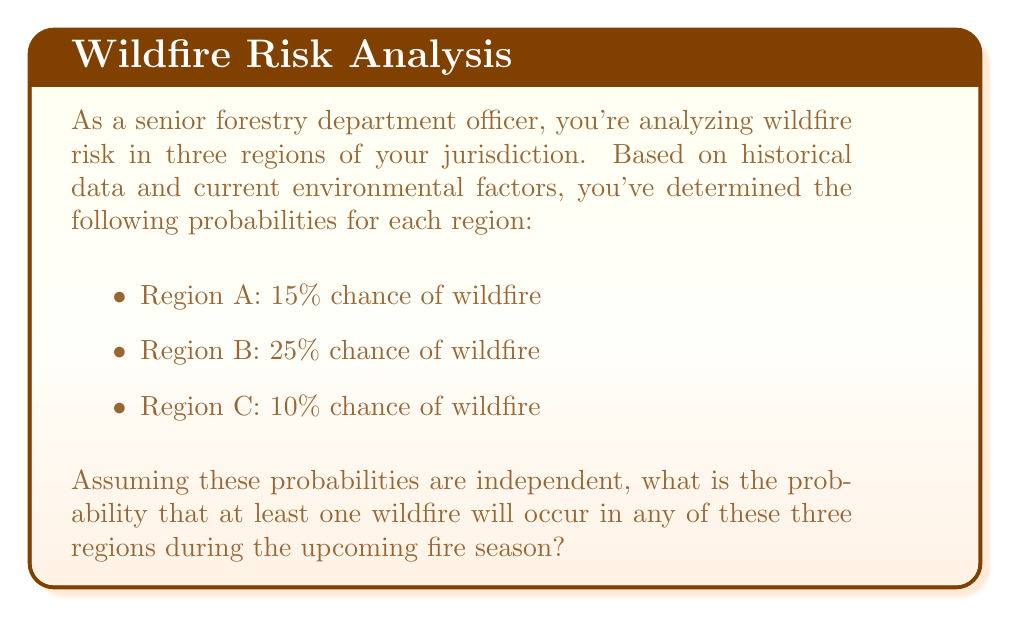Can you answer this question? To solve this problem, we'll use the complement rule of probability. Instead of calculating the probability of at least one wildfire occurring, we'll calculate the probability of no wildfires occurring and then subtract that from 1.

Let's break it down step-by-step:

1) First, let's calculate the probability of no wildfire occurring in each region:
   Region A: $1 - 0.15 = 0.85$
   Region B: $1 - 0.25 = 0.75$
   Region C: $1 - 0.10 = 0.90$

2) Since the probabilities are independent, we can multiply these probabilities to get the chance of no wildfires occurring in any of the three regions:

   $P(\text{no wildfires}) = 0.85 \times 0.75 \times 0.90 = 0.57375$

3) Now, we can use the complement rule to find the probability of at least one wildfire occurring:

   $P(\text{at least one wildfire}) = 1 - P(\text{no wildfires})$
   
   $P(\text{at least one wildfire}) = 1 - 0.57375 = 0.42625$

Therefore, the probability of at least one wildfire occurring in any of these three regions is approximately 0.42625 or 42.625%.
Answer: The probability that at least one wildfire will occur in any of the three regions is $0.42625$ or $42.625\%$. 